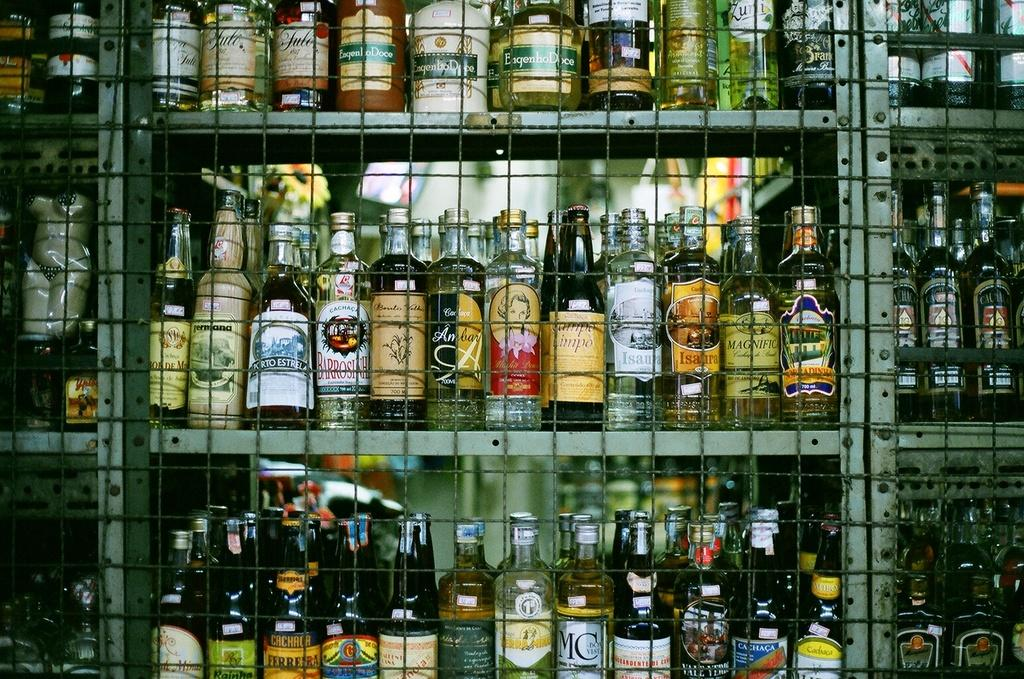<image>
Present a compact description of the photo's key features. a liquor cabinet with bottles including one with MC on it 